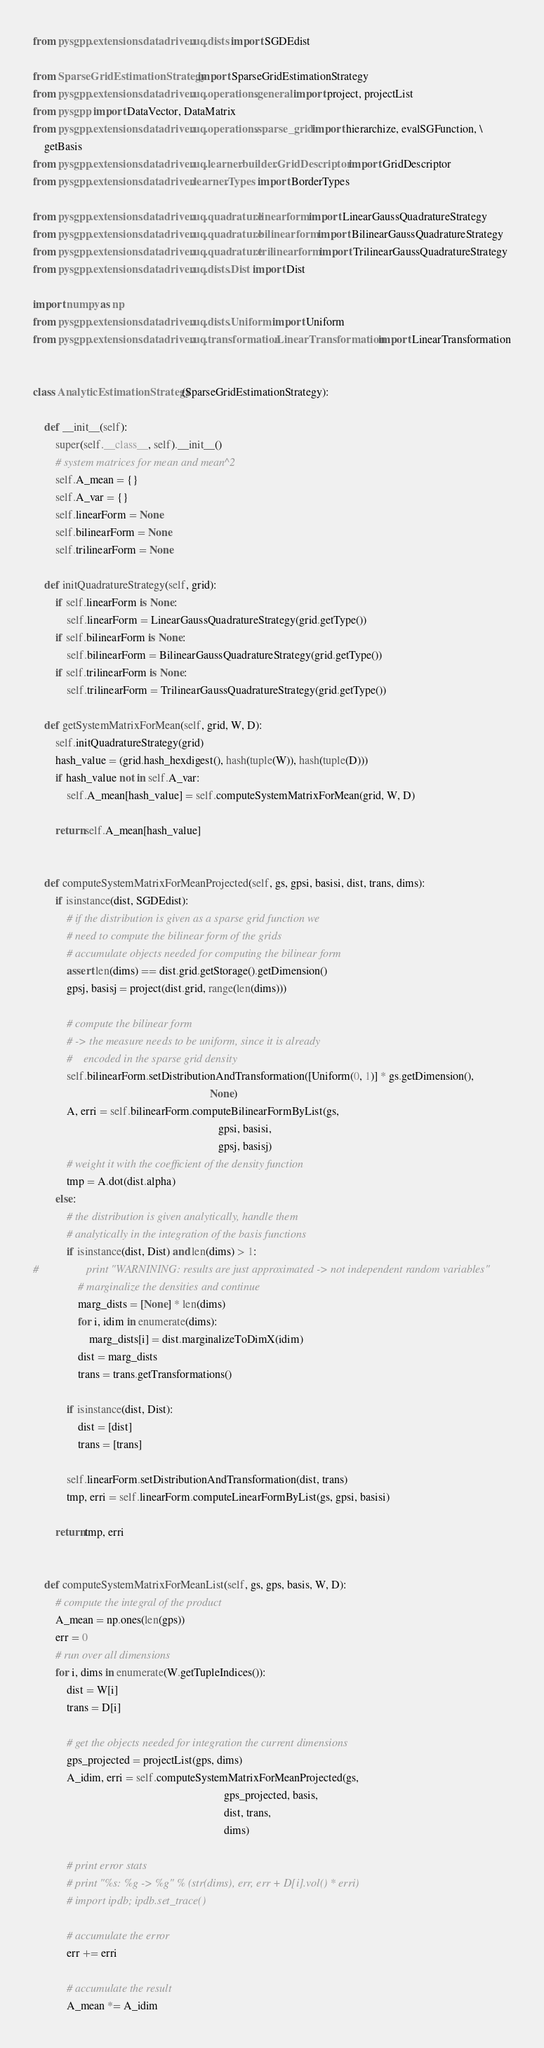Convert code to text. <code><loc_0><loc_0><loc_500><loc_500><_Python_>from pysgpp.extensions.datadriven.uq.dists import SGDEdist

from SparseGridEstimationStrategy import SparseGridEstimationStrategy
from pysgpp.extensions.datadriven.uq.operations.general import project, projectList
from pysgpp import DataVector, DataMatrix
from pysgpp.extensions.datadriven.uq.operations.sparse_grid import hierarchize, evalSGFunction, \
    getBasis
from pysgpp.extensions.datadriven.uq.learner.builder.GridDescriptor import GridDescriptor
from pysgpp.extensions.datadriven.learner.Types import BorderTypes

from pysgpp.extensions.datadriven.uq.quadrature.linearform import LinearGaussQuadratureStrategy
from pysgpp.extensions.datadriven.uq.quadrature.bilinearform import BilinearGaussQuadratureStrategy
from pysgpp.extensions.datadriven.uq.quadrature.trilinearform import TrilinearGaussQuadratureStrategy
from pysgpp.extensions.datadriven.uq.dists.Dist import Dist

import numpy as np
from pysgpp.extensions.datadriven.uq.dists.Uniform import Uniform
from pysgpp.extensions.datadriven.uq.transformation.LinearTransformation import LinearTransformation


class AnalyticEstimationStrategy(SparseGridEstimationStrategy):

    def __init__(self):
        super(self.__class__, self).__init__()
        # system matrices for mean and mean^2
        self.A_mean = {}
        self.A_var = {}
        self.linearForm = None
        self.bilinearForm = None
        self.trilinearForm = None

    def initQuadratureStrategy(self, grid):
        if self.linearForm is None:
            self.linearForm = LinearGaussQuadratureStrategy(grid.getType())
        if self.bilinearForm is None:
            self.bilinearForm = BilinearGaussQuadratureStrategy(grid.getType())
        if self.trilinearForm is None:
            self.trilinearForm = TrilinearGaussQuadratureStrategy(grid.getType())

    def getSystemMatrixForMean(self, grid, W, D):
        self.initQuadratureStrategy(grid)
        hash_value = (grid.hash_hexdigest(), hash(tuple(W)), hash(tuple(D)))
        if hash_value not in self.A_var:
            self.A_mean[hash_value] = self.computeSystemMatrixForMean(grid, W, D)

        return self.A_mean[hash_value]


    def computeSystemMatrixForMeanProjected(self, gs, gpsi, basisi, dist, trans, dims):
        if isinstance(dist, SGDEdist):
            # if the distribution is given as a sparse grid function we
            # need to compute the bilinear form of the grids
            # accumulate objects needed for computing the bilinear form
            assert len(dims) == dist.grid.getStorage().getDimension()
            gpsj, basisj = project(dist.grid, range(len(dims)))

            # compute the bilinear form
            # -> the measure needs to be uniform, since it is already
            #    encoded in the sparse grid density
            self.bilinearForm.setDistributionAndTransformation([Uniform(0, 1)] * gs.getDimension(),
                                                               None)
            A, erri = self.bilinearForm.computeBilinearFormByList(gs,
                                                                  gpsi, basisi,
                                                                  gpsj, basisj)
            # weight it with the coefficient of the density function
            tmp = A.dot(dist.alpha)
        else:
            # the distribution is given analytically, handle them
            # analytically in the integration of the basis functions
            if isinstance(dist, Dist) and len(dims) > 1:
#                 print "WARNINING: results are just approximated -> not independent random variables"
                # marginalize the densities and continue
                marg_dists = [None] * len(dims)
                for i, idim in enumerate(dims):
                    marg_dists[i] = dist.marginalizeToDimX(idim)
                dist = marg_dists
                trans = trans.getTransformations()

            if isinstance(dist, Dist):
                dist = [dist]
                trans = [trans]

            self.linearForm.setDistributionAndTransformation(dist, trans)
            tmp, erri = self.linearForm.computeLinearFormByList(gs, gpsi, basisi)

        return tmp, erri


    def computeSystemMatrixForMeanList(self, gs, gps, basis, W, D):
        # compute the integral of the product
        A_mean = np.ones(len(gps))
        err = 0
        # run over all dimensions
        for i, dims in enumerate(W.getTupleIndices()):
            dist = W[i]
            trans = D[i]

            # get the objects needed for integration the current dimensions
            gps_projected = projectList(gps, dims)
            A_idim, erri = self.computeSystemMatrixForMeanProjected(gs,
                                                                    gps_projected, basis,
                                                                    dist, trans,
                                                                    dims)

            # print error stats
            # print "%s: %g -> %g" % (str(dims), err, err + D[i].vol() * erri)
            # import ipdb; ipdb.set_trace()

            # accumulate the error
            err += erri

            # accumulate the result
            A_mean *= A_idim
</code> 